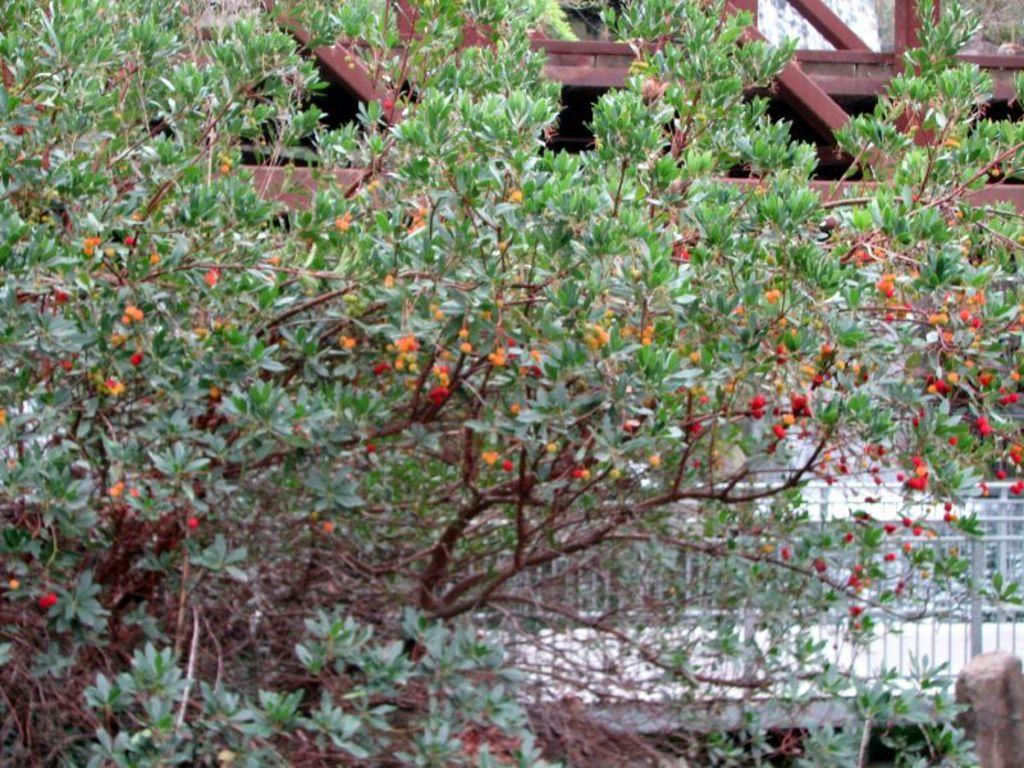What is located in the foreground of the image? There is a tree with leaves and fruits in the foreground of the image. What is attached to the tree? There is a wooden structure at the top of the tree. What can be seen in the background of the image? There is a railing in the background of the image. Reasoning: Let's think step by following the guidelines to produce the conversation. We start by identifying the main subject in the foreground, which is the tree with leaves and fruits. Then, we describe the wooden structure attached to the tree. Finally, we mention the railing visible in the background. Each question is designed to elicit a specific detail about the image that is known from the provided facts. Absurd Question/Answer: How many eggs are present on the tree in the image? There are no eggs present on the tree in the image. What part of the tree is talking to the railing in the background? Trees do not have the ability to talk, so there is no part of the tree communicating with the railing in the image. 